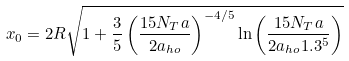Convert formula to latex. <formula><loc_0><loc_0><loc_500><loc_500>x _ { 0 } = 2 R \sqrt { 1 + \frac { 3 } { 5 } \left ( \frac { 1 5 N _ { T } a } { 2 a _ { h o } } \right ) ^ { - 4 / 5 } \ln \left ( \frac { 1 5 N _ { T } a } { 2 a _ { h o } 1 . 3 ^ { 5 } } \right ) }</formula> 